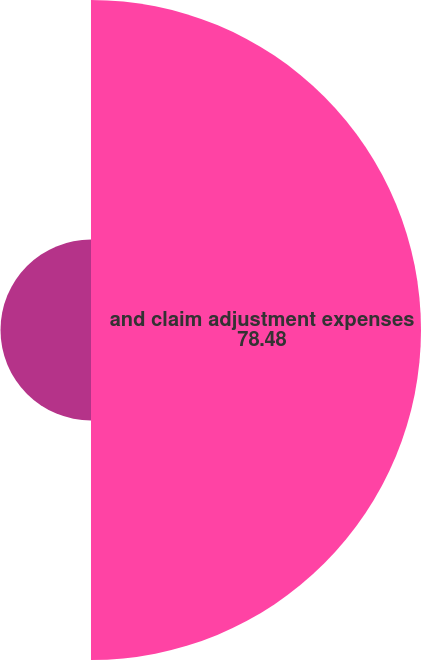Convert chart to OTSL. <chart><loc_0><loc_0><loc_500><loc_500><pie_chart><fcel>and claim adjustment expenses<fcel>Originally reported ceded<nl><fcel>78.48%<fcel>21.52%<nl></chart> 